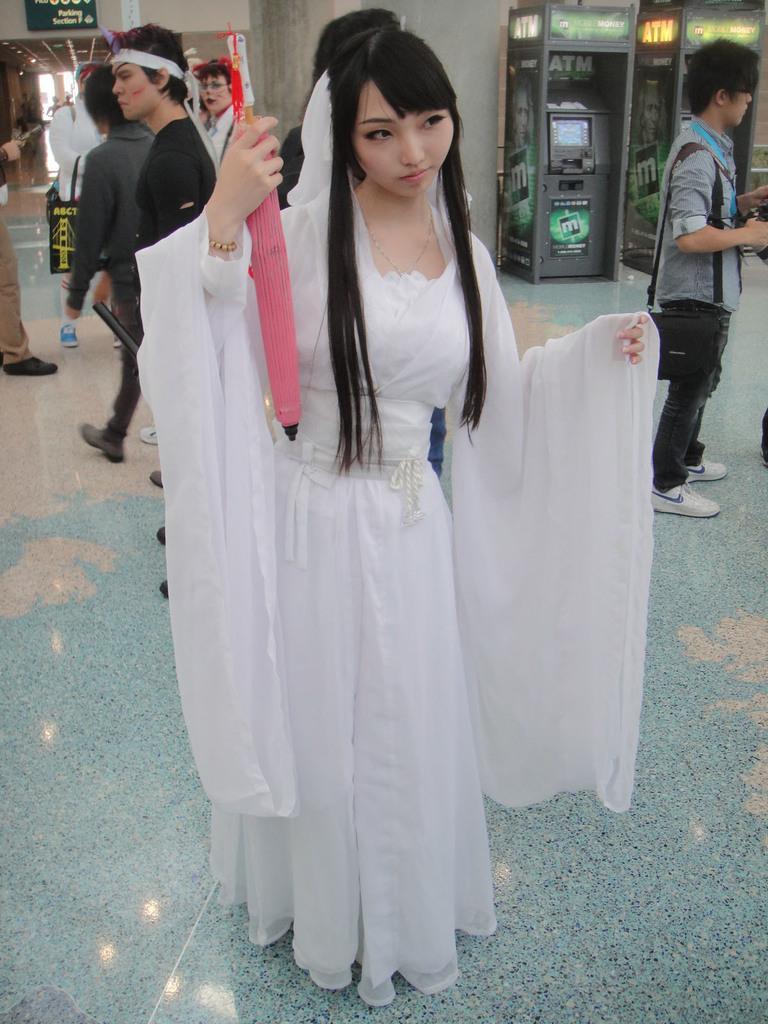How would you summarize this image in a sentence or two? In this picture we can see a group of people standing on the floor where a woman holding an object with her hand and in the background we can see machines, name board on the wall, lights. 